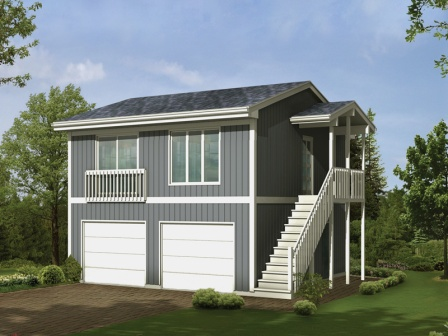Can you elaborate on the elements of the picture provided? The image features a well-designed two-story house adorned in a calming shade of gray, accentuated with pristine white trim. The architectural design includes a charming covered porch on the second floor, secured with a delicate white railing. A set of stairs elegantly descends from the porch, providing a graceful connection to the ground level. 

The first floor prominently showcases two spacious garage doors, hinting at considerable room for vehicles. This beautiful house is nestled amidst lush greenery, with trees and shrubs enhancing its natural charm. 

A brick-paved driveway, harmoniously blending with the surroundings, leads up to the garage doors, offering a convenient pathway for vehicles. Together, the house, driveway, and surrounding foliage create a tranquil and inviting residential scene. 